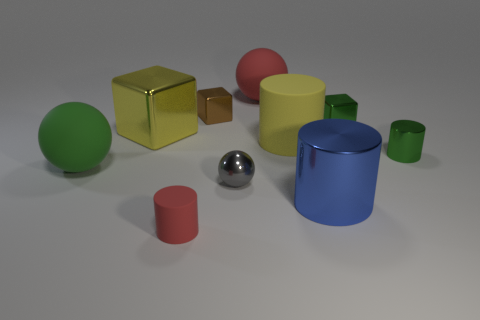Subtract all small green metal blocks. How many blocks are left? 2 Subtract all yellow cylinders. How many cylinders are left? 3 Subtract all balls. How many objects are left? 7 Subtract 2 blocks. How many blocks are left? 1 Subtract all red cylinders. How many red cubes are left? 0 Subtract all green cubes. Subtract all purple balls. How many cubes are left? 2 Subtract all brown blocks. Subtract all tiny gray shiny things. How many objects are left? 8 Add 3 large red matte things. How many large red matte things are left? 4 Add 6 blue metal cylinders. How many blue metal cylinders exist? 7 Subtract 1 red cylinders. How many objects are left? 9 